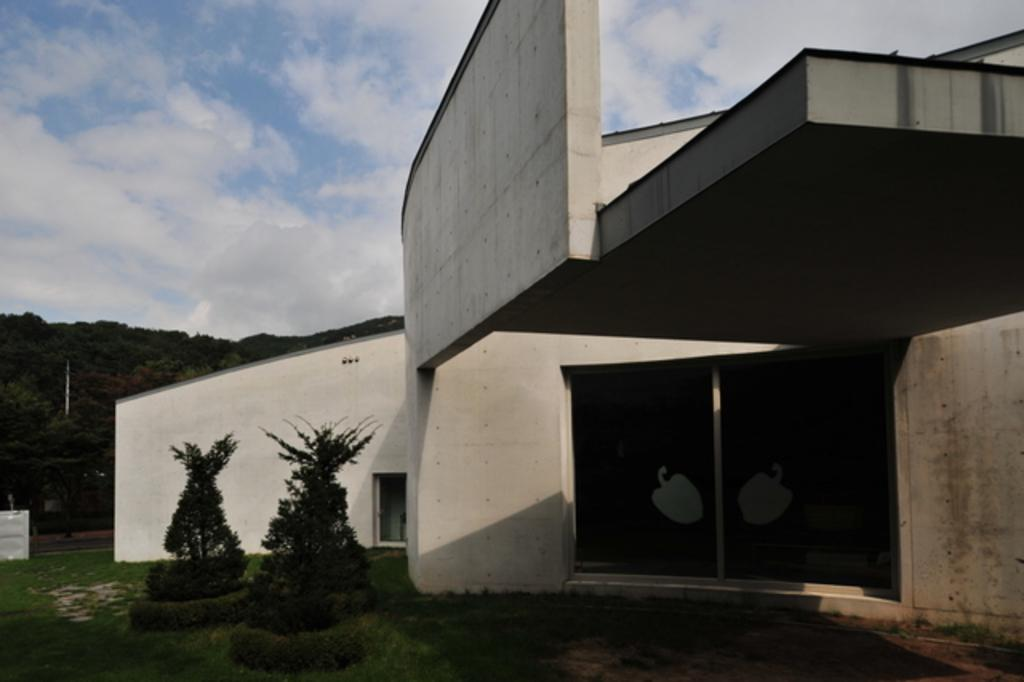What type of vegetation is located in front of the building in the image? A: There are plants in front of the building in the image. What geographical feature can be seen on the left side of the image? There is a hill on the left side of the image. What is visible at the top of the image? The sky is visible at the top of the image. Can you see a border between the plants and the building in the image? There is no mention of a border in the image, as it only states that there are plants in front of the building. Are there any animals biting the plants in the image? There is no indication of any animals or biting in the image, as it only mentions the presence of plants and a building. 